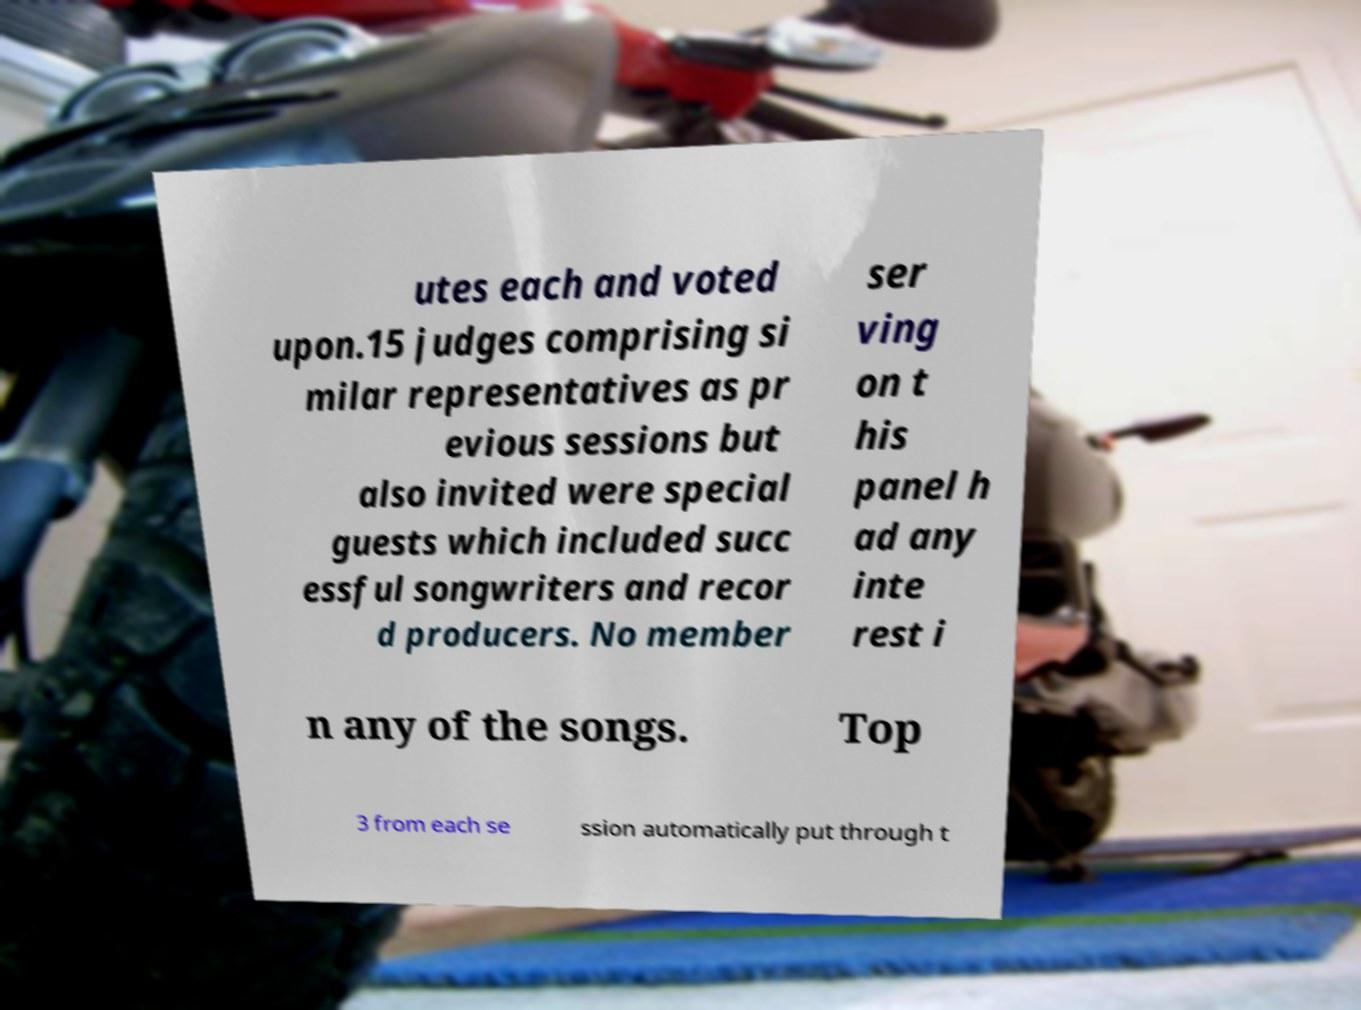Can you read and provide the text displayed in the image?This photo seems to have some interesting text. Can you extract and type it out for me? utes each and voted upon.15 judges comprising si milar representatives as pr evious sessions but also invited were special guests which included succ essful songwriters and recor d producers. No member ser ving on t his panel h ad any inte rest i n any of the songs. Top 3 from each se ssion automatically put through t 